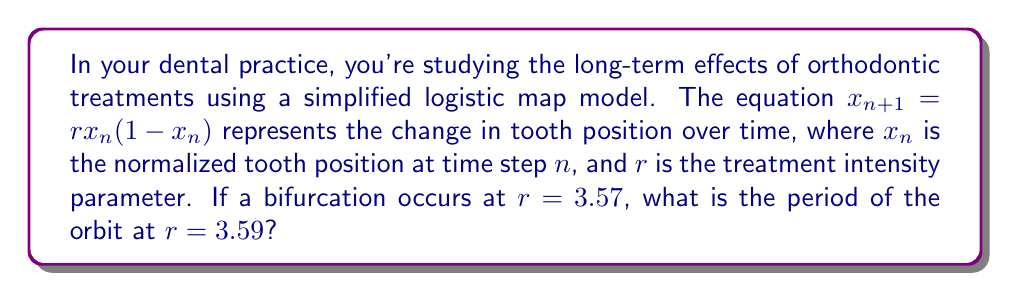Solve this math problem. To solve this problem, we need to understand the behavior of the logistic map and its bifurcation diagram:

1) The logistic map $x_{n+1} = rx_n(1-x_n)$ is a classic example in chaos theory, often used to model population dynamics but adaptable to other systems like orthodontic treatments.

2) As the parameter $r$ increases, the system undergoes a series of period-doubling bifurcations before entering chaos.

3) The bifurcation at $r = 3.57$ is significant because it's close to the onset of chaos, which occurs at approximately $r ≈ 3.56995$.

4) After this point, the system alternates between periodic windows and chaotic regions.

5) At $r = 3.59$, the system is in a periodic window that emerges just after the onset of chaos.

6) This specific periodic window is known to have a period-3 orbit.

7) We can verify this by iterating the map:

   Let $x_0 = 0.5$ (arbitrary initial condition)
   
   $x_1 = 3.59 * 0.5 * (1-0.5) = 0.8975$
   $x_2 = 3.59 * 0.8975 * (1-0.8975) = 0.3296$
   $x_3 = 3.59 * 0.3296 * (1-0.3296) = 0.7923$
   $x_4 = 3.59 * 0.7923 * (1-0.7923) = 0.5903$
   $x_5 = 3.59 * 0.5903 * (1-0.5903) = 0.8678$
   $x_6 = 3.59 * 0.8678 * (1-0.8678) = 0.4119$
   $x_7 = 3.59 * 0.4119 * (1-0.4119) = 0.8701$

8) We can see that the values start to repeat after every 3 iterations, confirming a period-3 orbit.
Answer: 3 